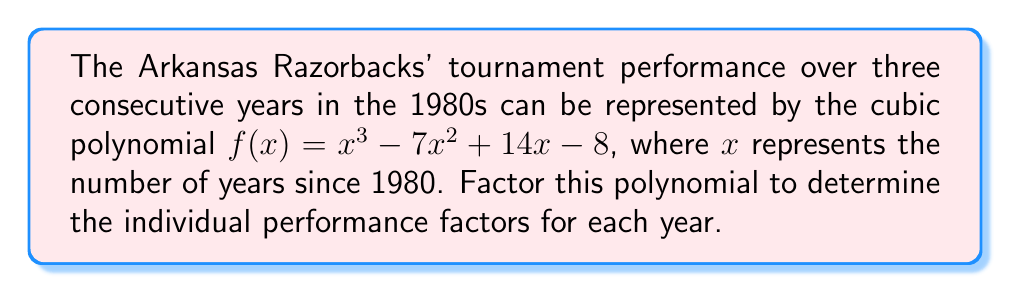Could you help me with this problem? To factor this cubic polynomial, we'll follow these steps:

1) First, let's check if there's a rational root. We can use the rational root theorem to list possible roots:
   Factors of 8: $\pm 1, \pm 2, \pm 4, \pm 8$

2) Testing these values, we find that $f(1) = 0$. So $(x-1)$ is a factor.

3) We can use polynomial long division to divide $f(x)$ by $(x-1)$:

   $$\frac{x^3 - 7x^2 + 14x - 8}{x - 1} = x^2 - 6x + 8$$

4) So, $f(x) = (x-1)(x^2 - 6x + 8)$

5) Now we need to factor the quadratic $x^2 - 6x + 8$. We can use the quadratic formula or factoring by grouping.

6) The quadratic factors as $(x-2)(x-4)$

Therefore, the complete factorization is:

$f(x) = (x-1)(x-2)(x-4)$

This factorization represents the team's performance factors for each of the three years, with roots at $x = 1$, $x = 2$, and $x = 4$, corresponding to 1981, 1982, and 1984 respectively.
Answer: $f(x) = (x-1)(x-2)(x-4)$ 